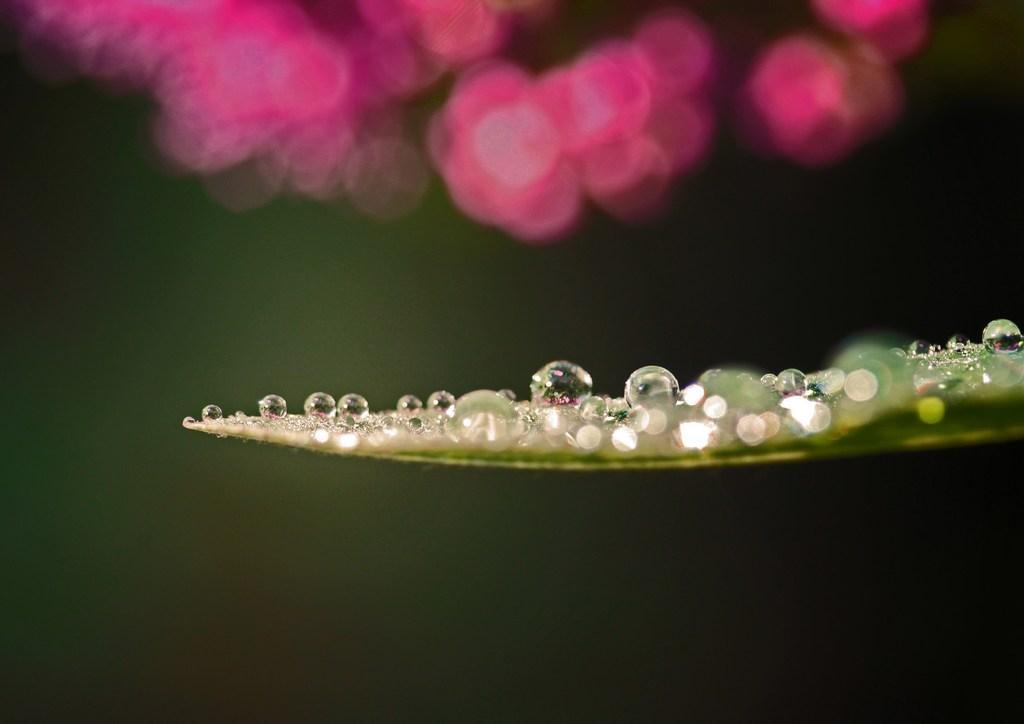Could you give a brief overview of what you see in this image? On the right side, there are water drops on a leaf. At the top of this image, there are pink color objects. And the background is dark in color. 